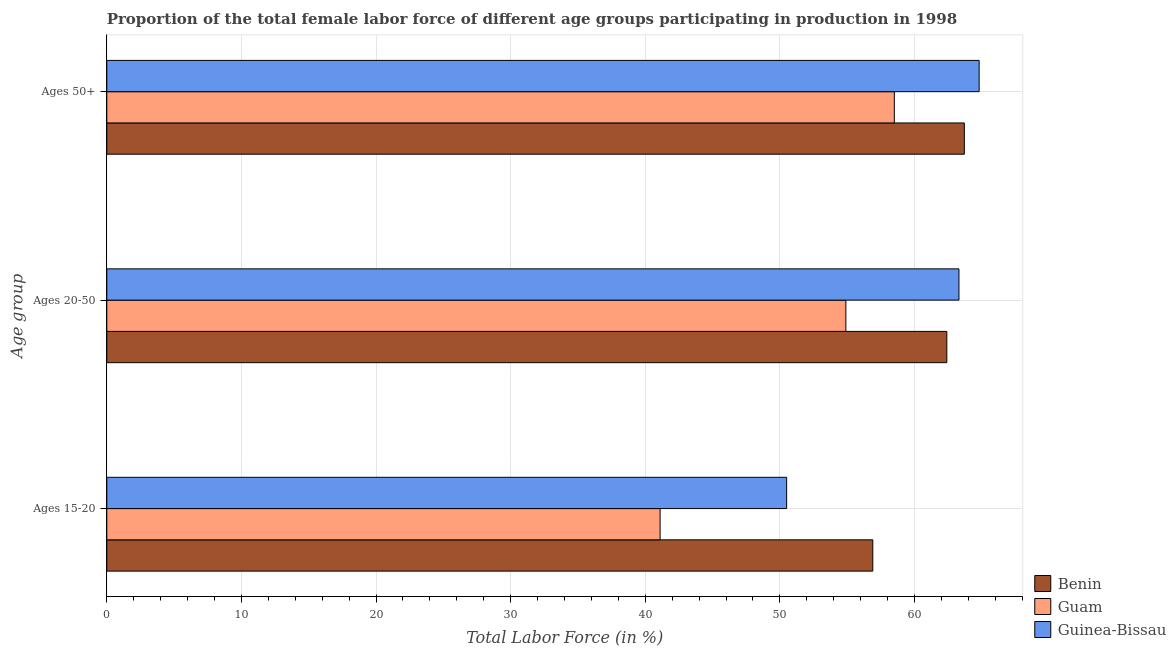How many different coloured bars are there?
Keep it short and to the point. 3. Are the number of bars per tick equal to the number of legend labels?
Provide a succinct answer. Yes. Are the number of bars on each tick of the Y-axis equal?
Provide a succinct answer. Yes. How many bars are there on the 1st tick from the bottom?
Give a very brief answer. 3. What is the label of the 1st group of bars from the top?
Your answer should be very brief. Ages 50+. What is the percentage of female labor force within the age group 20-50 in Guam?
Provide a short and direct response. 54.9. Across all countries, what is the maximum percentage of female labor force within the age group 20-50?
Offer a terse response. 63.3. Across all countries, what is the minimum percentage of female labor force within the age group 15-20?
Make the answer very short. 41.1. In which country was the percentage of female labor force within the age group 20-50 maximum?
Your response must be concise. Guinea-Bissau. In which country was the percentage of female labor force above age 50 minimum?
Your answer should be very brief. Guam. What is the total percentage of female labor force within the age group 20-50 in the graph?
Ensure brevity in your answer.  180.6. What is the difference between the percentage of female labor force within the age group 15-20 in Guam and that in Guinea-Bissau?
Offer a terse response. -9.4. What is the difference between the percentage of female labor force above age 50 in Guam and the percentage of female labor force within the age group 15-20 in Benin?
Make the answer very short. 1.6. What is the average percentage of female labor force above age 50 per country?
Give a very brief answer. 62.33. What is the difference between the percentage of female labor force within the age group 20-50 and percentage of female labor force within the age group 15-20 in Guam?
Make the answer very short. 13.8. In how many countries, is the percentage of female labor force above age 50 greater than 34 %?
Provide a succinct answer. 3. What is the ratio of the percentage of female labor force within the age group 20-50 in Guinea-Bissau to that in Benin?
Your response must be concise. 1.01. Is the percentage of female labor force within the age group 15-20 in Guinea-Bissau less than that in Guam?
Give a very brief answer. No. What is the difference between the highest and the second highest percentage of female labor force within the age group 20-50?
Offer a terse response. 0.9. What is the difference between the highest and the lowest percentage of female labor force above age 50?
Your answer should be compact. 6.3. In how many countries, is the percentage of female labor force above age 50 greater than the average percentage of female labor force above age 50 taken over all countries?
Provide a short and direct response. 2. What does the 3rd bar from the top in Ages 50+ represents?
Give a very brief answer. Benin. What does the 1st bar from the bottom in Ages 50+ represents?
Offer a terse response. Benin. Does the graph contain any zero values?
Your answer should be very brief. No. How are the legend labels stacked?
Give a very brief answer. Vertical. What is the title of the graph?
Give a very brief answer. Proportion of the total female labor force of different age groups participating in production in 1998. What is the label or title of the X-axis?
Ensure brevity in your answer.  Total Labor Force (in %). What is the label or title of the Y-axis?
Provide a succinct answer. Age group. What is the Total Labor Force (in %) in Benin in Ages 15-20?
Your answer should be compact. 56.9. What is the Total Labor Force (in %) in Guam in Ages 15-20?
Give a very brief answer. 41.1. What is the Total Labor Force (in %) of Guinea-Bissau in Ages 15-20?
Your response must be concise. 50.5. What is the Total Labor Force (in %) in Benin in Ages 20-50?
Your answer should be very brief. 62.4. What is the Total Labor Force (in %) in Guam in Ages 20-50?
Provide a short and direct response. 54.9. What is the Total Labor Force (in %) of Guinea-Bissau in Ages 20-50?
Give a very brief answer. 63.3. What is the Total Labor Force (in %) of Benin in Ages 50+?
Make the answer very short. 63.7. What is the Total Labor Force (in %) in Guam in Ages 50+?
Your answer should be very brief. 58.5. What is the Total Labor Force (in %) in Guinea-Bissau in Ages 50+?
Make the answer very short. 64.8. Across all Age group, what is the maximum Total Labor Force (in %) in Benin?
Your answer should be very brief. 63.7. Across all Age group, what is the maximum Total Labor Force (in %) in Guam?
Keep it short and to the point. 58.5. Across all Age group, what is the maximum Total Labor Force (in %) in Guinea-Bissau?
Ensure brevity in your answer.  64.8. Across all Age group, what is the minimum Total Labor Force (in %) of Benin?
Give a very brief answer. 56.9. Across all Age group, what is the minimum Total Labor Force (in %) of Guam?
Your answer should be very brief. 41.1. Across all Age group, what is the minimum Total Labor Force (in %) in Guinea-Bissau?
Provide a succinct answer. 50.5. What is the total Total Labor Force (in %) in Benin in the graph?
Provide a succinct answer. 183. What is the total Total Labor Force (in %) in Guam in the graph?
Make the answer very short. 154.5. What is the total Total Labor Force (in %) in Guinea-Bissau in the graph?
Offer a terse response. 178.6. What is the difference between the Total Labor Force (in %) of Benin in Ages 15-20 and that in Ages 20-50?
Your answer should be compact. -5.5. What is the difference between the Total Labor Force (in %) in Guam in Ages 15-20 and that in Ages 50+?
Your answer should be compact. -17.4. What is the difference between the Total Labor Force (in %) in Guinea-Bissau in Ages 15-20 and that in Ages 50+?
Give a very brief answer. -14.3. What is the difference between the Total Labor Force (in %) of Benin in Ages 20-50 and that in Ages 50+?
Ensure brevity in your answer.  -1.3. What is the difference between the Total Labor Force (in %) of Guam in Ages 20-50 and that in Ages 50+?
Provide a short and direct response. -3.6. What is the difference between the Total Labor Force (in %) of Benin in Ages 15-20 and the Total Labor Force (in %) of Guam in Ages 20-50?
Your response must be concise. 2. What is the difference between the Total Labor Force (in %) of Guam in Ages 15-20 and the Total Labor Force (in %) of Guinea-Bissau in Ages 20-50?
Provide a short and direct response. -22.2. What is the difference between the Total Labor Force (in %) of Benin in Ages 15-20 and the Total Labor Force (in %) of Guam in Ages 50+?
Your response must be concise. -1.6. What is the difference between the Total Labor Force (in %) in Benin in Ages 15-20 and the Total Labor Force (in %) in Guinea-Bissau in Ages 50+?
Keep it short and to the point. -7.9. What is the difference between the Total Labor Force (in %) in Guam in Ages 15-20 and the Total Labor Force (in %) in Guinea-Bissau in Ages 50+?
Offer a terse response. -23.7. What is the difference between the Total Labor Force (in %) of Benin in Ages 20-50 and the Total Labor Force (in %) of Guinea-Bissau in Ages 50+?
Your answer should be very brief. -2.4. What is the average Total Labor Force (in %) of Guam per Age group?
Offer a terse response. 51.5. What is the average Total Labor Force (in %) of Guinea-Bissau per Age group?
Make the answer very short. 59.53. What is the difference between the Total Labor Force (in %) in Benin and Total Labor Force (in %) in Guinea-Bissau in Ages 15-20?
Provide a short and direct response. 6.4. What is the difference between the Total Labor Force (in %) of Guam and Total Labor Force (in %) of Guinea-Bissau in Ages 15-20?
Ensure brevity in your answer.  -9.4. What is the difference between the Total Labor Force (in %) of Guam and Total Labor Force (in %) of Guinea-Bissau in Ages 20-50?
Make the answer very short. -8.4. What is the difference between the Total Labor Force (in %) in Benin and Total Labor Force (in %) in Guam in Ages 50+?
Your answer should be compact. 5.2. What is the difference between the Total Labor Force (in %) of Benin and Total Labor Force (in %) of Guinea-Bissau in Ages 50+?
Provide a succinct answer. -1.1. What is the difference between the Total Labor Force (in %) of Guam and Total Labor Force (in %) of Guinea-Bissau in Ages 50+?
Your answer should be very brief. -6.3. What is the ratio of the Total Labor Force (in %) in Benin in Ages 15-20 to that in Ages 20-50?
Your answer should be compact. 0.91. What is the ratio of the Total Labor Force (in %) of Guam in Ages 15-20 to that in Ages 20-50?
Give a very brief answer. 0.75. What is the ratio of the Total Labor Force (in %) in Guinea-Bissau in Ages 15-20 to that in Ages 20-50?
Offer a terse response. 0.8. What is the ratio of the Total Labor Force (in %) of Benin in Ages 15-20 to that in Ages 50+?
Your answer should be very brief. 0.89. What is the ratio of the Total Labor Force (in %) of Guam in Ages 15-20 to that in Ages 50+?
Ensure brevity in your answer.  0.7. What is the ratio of the Total Labor Force (in %) of Guinea-Bissau in Ages 15-20 to that in Ages 50+?
Ensure brevity in your answer.  0.78. What is the ratio of the Total Labor Force (in %) of Benin in Ages 20-50 to that in Ages 50+?
Provide a short and direct response. 0.98. What is the ratio of the Total Labor Force (in %) in Guam in Ages 20-50 to that in Ages 50+?
Ensure brevity in your answer.  0.94. What is the ratio of the Total Labor Force (in %) of Guinea-Bissau in Ages 20-50 to that in Ages 50+?
Provide a succinct answer. 0.98. What is the difference between the highest and the second highest Total Labor Force (in %) in Guam?
Your response must be concise. 3.6. What is the difference between the highest and the second highest Total Labor Force (in %) in Guinea-Bissau?
Give a very brief answer. 1.5. What is the difference between the highest and the lowest Total Labor Force (in %) of Benin?
Provide a short and direct response. 6.8. What is the difference between the highest and the lowest Total Labor Force (in %) in Guam?
Your answer should be very brief. 17.4. What is the difference between the highest and the lowest Total Labor Force (in %) in Guinea-Bissau?
Keep it short and to the point. 14.3. 